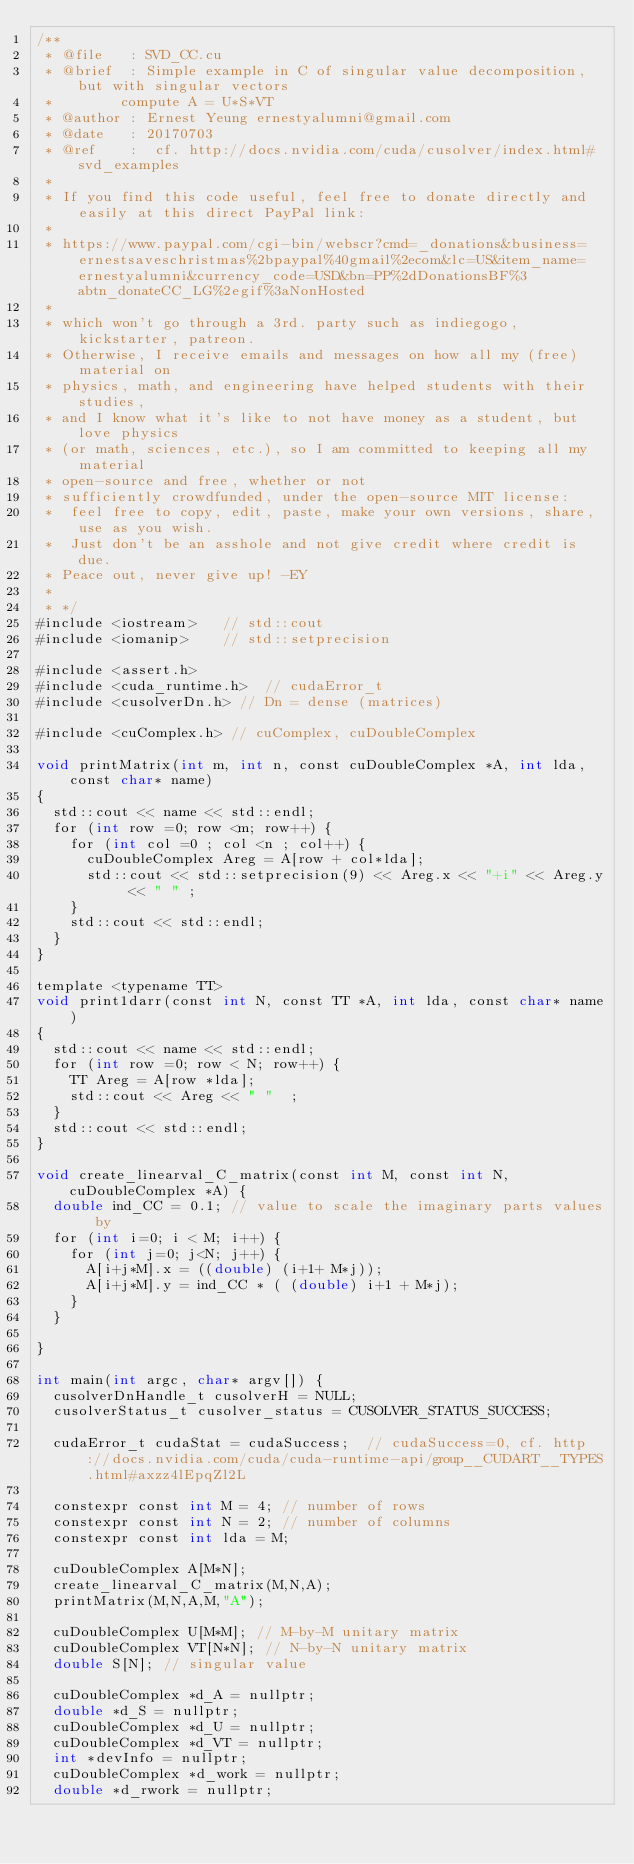<code> <loc_0><loc_0><loc_500><loc_500><_Cuda_>/**
 * @file   : SVD_CC.cu
 * @brief  : Simple example in C of singular value decomposition, but with singular vectors
 * 				compute A = U*S*VT
 * @author : Ernest Yeung	ernestyalumni@gmail.com
 * @date   : 20170703
 * @ref    :  cf. http://docs.nvidia.com/cuda/cusolver/index.html#svd_examples
 * 
 * If you find this code useful, feel free to donate directly and easily at this direct PayPal link: 
 * 
 * https://www.paypal.com/cgi-bin/webscr?cmd=_donations&business=ernestsaveschristmas%2bpaypal%40gmail%2ecom&lc=US&item_name=ernestyalumni&currency_code=USD&bn=PP%2dDonationsBF%3abtn_donateCC_LG%2egif%3aNonHosted 
 * 
 * which won't go through a 3rd. party such as indiegogo, kickstarter, patreon.  
 * Otherwise, I receive emails and messages on how all my (free) material on 
 * physics, math, and engineering have helped students with their studies, 
 * and I know what it's like to not have money as a student, but love physics 
 * (or math, sciences, etc.), so I am committed to keeping all my material 
 * open-source and free, whether or not 
 * sufficiently crowdfunded, under the open-source MIT license: 
 * 	feel free to copy, edit, paste, make your own versions, share, use as you wish.  
 *  Just don't be an asshole and not give credit where credit is due.  
 * Peace out, never give up! -EY
 * 
 * */
#include <iostream> 	// std::cout
#include <iomanip> 		// std::setprecision 

#include <assert.h>
#include <cuda_runtime.h>  // cudaError_t
#include <cusolverDn.h> // Dn = dense (matrices)

#include <cuComplex.h> // cuComplex, cuDoubleComplex

void printMatrix(int m, int n, const cuDoubleComplex *A, int lda, const char* name) 
{
	std::cout << name << std::endl;
	for (int row =0; row <m; row++) {
		for (int col =0 ; col <n ; col++) {
			cuDoubleComplex Areg = A[row + col*lda]; 
			std::cout << std::setprecision(9) << Areg.x << "+i" << Areg.y << " " ; 
		}
		std::cout << std::endl;
	}
}

template <typename TT>
void print1darr(const int N, const TT *A, int lda, const char* name) 
{
	std::cout << name << std::endl;
	for (int row =0; row < N; row++) {
		TT Areg = A[row *lda]; 
		std::cout << Areg << " "  ; 
	}
	std::cout << std::endl;
}

void create_linearval_C_matrix(const int M, const int N, cuDoubleComplex *A) {
	double ind_CC = 0.1; // value to scale the imaginary parts values by
	for (int i=0; i < M; i++) { 
		for (int j=0; j<N; j++) { 
			A[i+j*M].x = ((double) (i+1+ M*j));
			A[i+j*M].y = ind_CC * ( (double) i+1 + M*j); 
		}
	}
	
}

int main(int argc, char* argv[]) {
	cusolverDnHandle_t cusolverH = NULL;
	cusolverStatus_t cusolver_status = CUSOLVER_STATUS_SUCCESS;

	cudaError_t cudaStat = cudaSuccess;  // cudaSuccess=0, cf. http://docs.nvidia.com/cuda/cuda-runtime-api/group__CUDART__TYPES.html#axzz4lEpqZl2L
	
	constexpr const int M = 4; // number of rows 
	constexpr const int N = 2; // number of columns  
	constexpr const int lda = M; 

	cuDoubleComplex A[M*N]; 
	create_linearval_C_matrix(M,N,A); 
	printMatrix(M,N,A,M,"A"); 
	
	cuDoubleComplex U[M*M]; // M-by-M unitary matrix
	cuDoubleComplex VT[N*N]; // N-by-N unitary matrix
	double S[N]; // singular value
	
	cuDoubleComplex *d_A = nullptr; 
	double *d_S = nullptr; 
	cuDoubleComplex *d_U = nullptr; 
	cuDoubleComplex *d_VT = nullptr; 
	int *devInfo = nullptr; 
	cuDoubleComplex *d_work = nullptr; 
	double *d_rwork = nullptr; </code> 